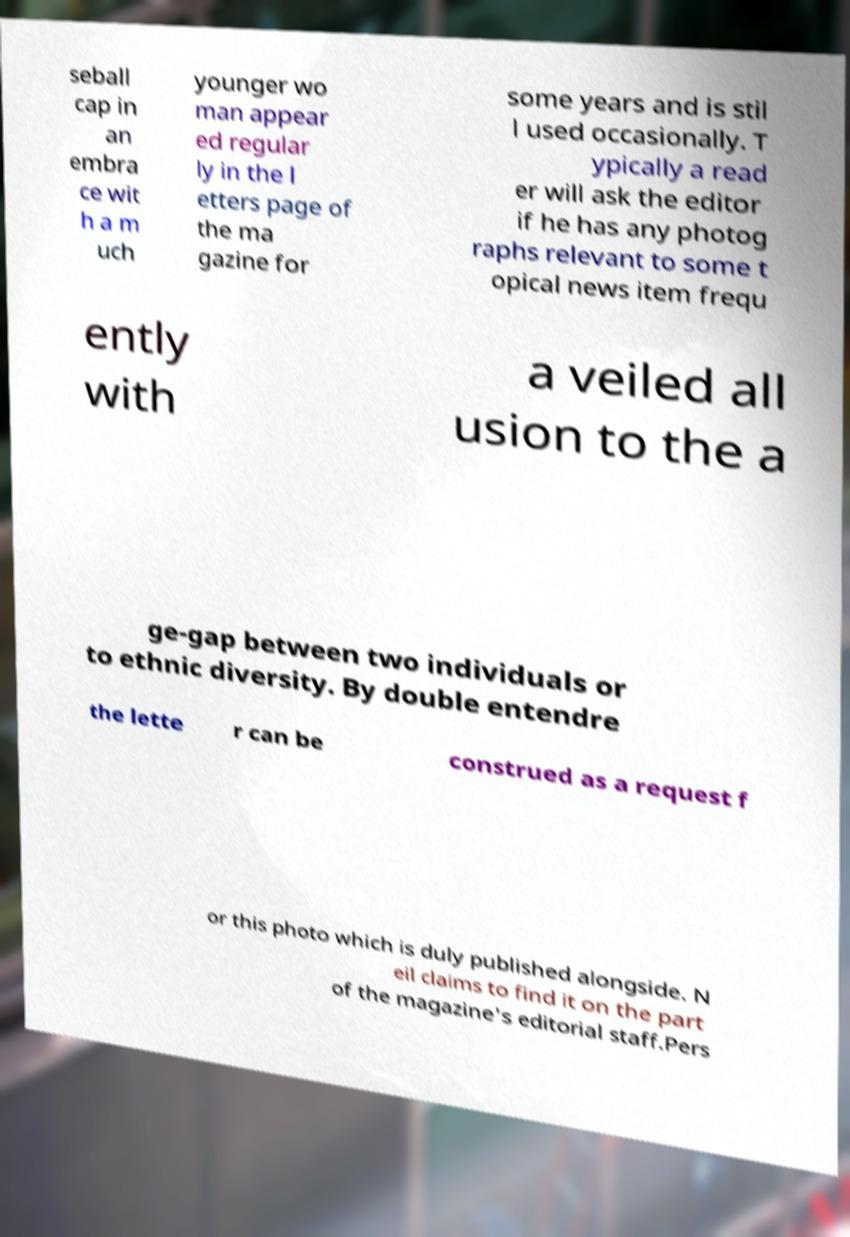Could you extract and type out the text from this image? seball cap in an embra ce wit h a m uch younger wo man appear ed regular ly in the l etters page of the ma gazine for some years and is stil l used occasionally. T ypically a read er will ask the editor if he has any photog raphs relevant to some t opical news item frequ ently with a veiled all usion to the a ge-gap between two individuals or to ethnic diversity. By double entendre the lette r can be construed as a request f or this photo which is duly published alongside. N eil claims to find it on the part of the magazine's editorial staff.Pers 